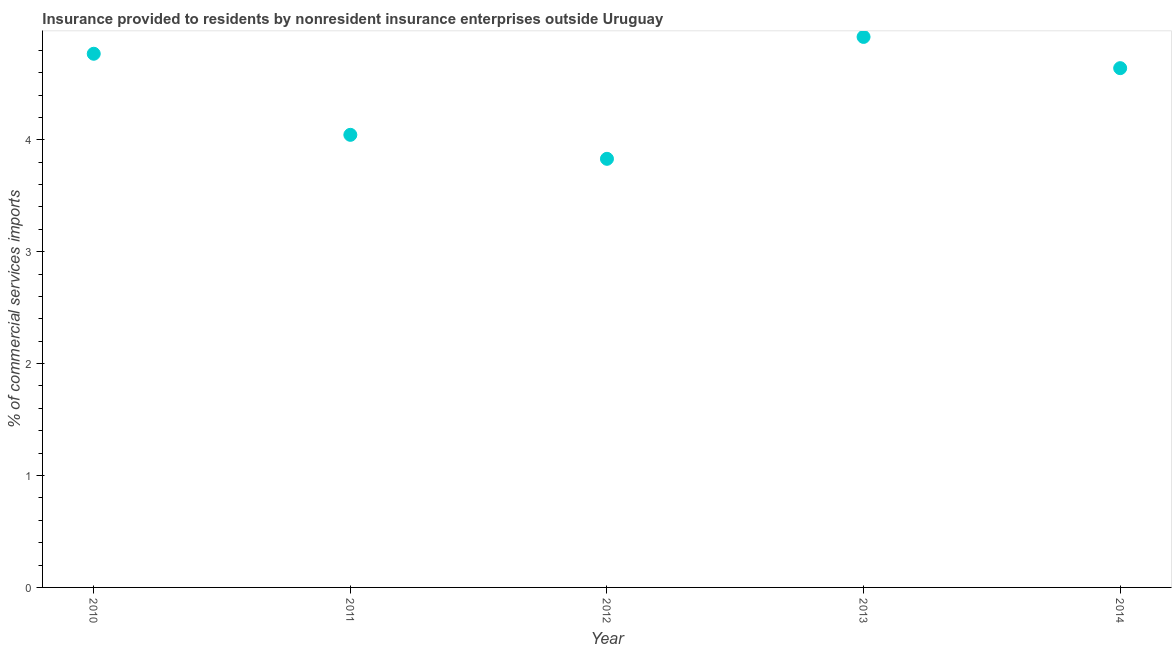What is the insurance provided by non-residents in 2014?
Offer a very short reply. 4.64. Across all years, what is the maximum insurance provided by non-residents?
Give a very brief answer. 4.92. Across all years, what is the minimum insurance provided by non-residents?
Your response must be concise. 3.83. In which year was the insurance provided by non-residents minimum?
Your response must be concise. 2012. What is the sum of the insurance provided by non-residents?
Make the answer very short. 22.2. What is the difference between the insurance provided by non-residents in 2011 and 2012?
Provide a short and direct response. 0.21. What is the average insurance provided by non-residents per year?
Your answer should be compact. 4.44. What is the median insurance provided by non-residents?
Provide a short and direct response. 4.64. Do a majority of the years between 2013 and 2012 (inclusive) have insurance provided by non-residents greater than 3.4 %?
Provide a succinct answer. No. What is the ratio of the insurance provided by non-residents in 2012 to that in 2014?
Give a very brief answer. 0.83. Is the insurance provided by non-residents in 2011 less than that in 2012?
Your response must be concise. No. Is the difference between the insurance provided by non-residents in 2012 and 2013 greater than the difference between any two years?
Your answer should be very brief. Yes. What is the difference between the highest and the second highest insurance provided by non-residents?
Your response must be concise. 0.15. Is the sum of the insurance provided by non-residents in 2012 and 2013 greater than the maximum insurance provided by non-residents across all years?
Your response must be concise. Yes. What is the difference between the highest and the lowest insurance provided by non-residents?
Your answer should be compact. 1.09. In how many years, is the insurance provided by non-residents greater than the average insurance provided by non-residents taken over all years?
Your response must be concise. 3. How many dotlines are there?
Make the answer very short. 1. What is the difference between two consecutive major ticks on the Y-axis?
Offer a terse response. 1. Does the graph contain grids?
Provide a succinct answer. No. What is the title of the graph?
Offer a very short reply. Insurance provided to residents by nonresident insurance enterprises outside Uruguay. What is the label or title of the X-axis?
Offer a terse response. Year. What is the label or title of the Y-axis?
Your answer should be compact. % of commercial services imports. What is the % of commercial services imports in 2010?
Keep it short and to the point. 4.77. What is the % of commercial services imports in 2011?
Your response must be concise. 4.04. What is the % of commercial services imports in 2012?
Keep it short and to the point. 3.83. What is the % of commercial services imports in 2013?
Your answer should be compact. 4.92. What is the % of commercial services imports in 2014?
Make the answer very short. 4.64. What is the difference between the % of commercial services imports in 2010 and 2011?
Your answer should be compact. 0.72. What is the difference between the % of commercial services imports in 2010 and 2012?
Ensure brevity in your answer.  0.94. What is the difference between the % of commercial services imports in 2010 and 2013?
Keep it short and to the point. -0.15. What is the difference between the % of commercial services imports in 2010 and 2014?
Keep it short and to the point. 0.13. What is the difference between the % of commercial services imports in 2011 and 2012?
Offer a very short reply. 0.21. What is the difference between the % of commercial services imports in 2011 and 2013?
Offer a terse response. -0.87. What is the difference between the % of commercial services imports in 2011 and 2014?
Ensure brevity in your answer.  -0.6. What is the difference between the % of commercial services imports in 2012 and 2013?
Your answer should be compact. -1.09. What is the difference between the % of commercial services imports in 2012 and 2014?
Your answer should be very brief. -0.81. What is the difference between the % of commercial services imports in 2013 and 2014?
Offer a terse response. 0.28. What is the ratio of the % of commercial services imports in 2010 to that in 2011?
Provide a short and direct response. 1.18. What is the ratio of the % of commercial services imports in 2010 to that in 2012?
Provide a short and direct response. 1.25. What is the ratio of the % of commercial services imports in 2010 to that in 2014?
Your answer should be very brief. 1.03. What is the ratio of the % of commercial services imports in 2011 to that in 2012?
Provide a short and direct response. 1.06. What is the ratio of the % of commercial services imports in 2011 to that in 2013?
Give a very brief answer. 0.82. What is the ratio of the % of commercial services imports in 2011 to that in 2014?
Your response must be concise. 0.87. What is the ratio of the % of commercial services imports in 2012 to that in 2013?
Give a very brief answer. 0.78. What is the ratio of the % of commercial services imports in 2012 to that in 2014?
Your response must be concise. 0.82. What is the ratio of the % of commercial services imports in 2013 to that in 2014?
Provide a succinct answer. 1.06. 